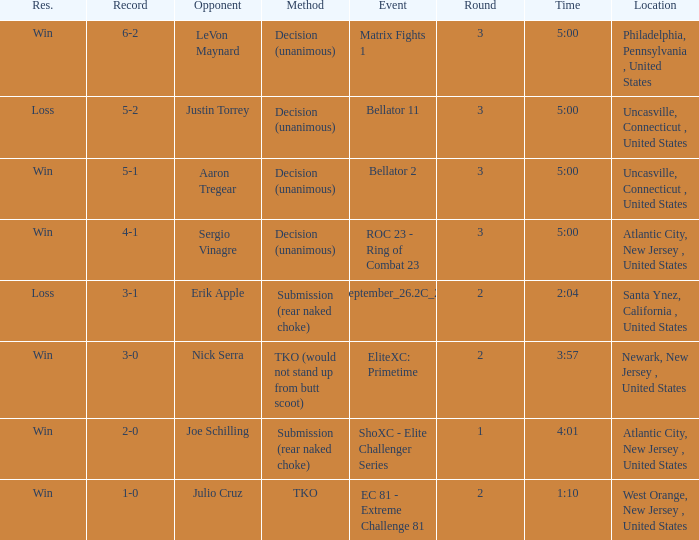What round was it when the method was TKO (would not stand up from Butt Scoot)? 2.0. 